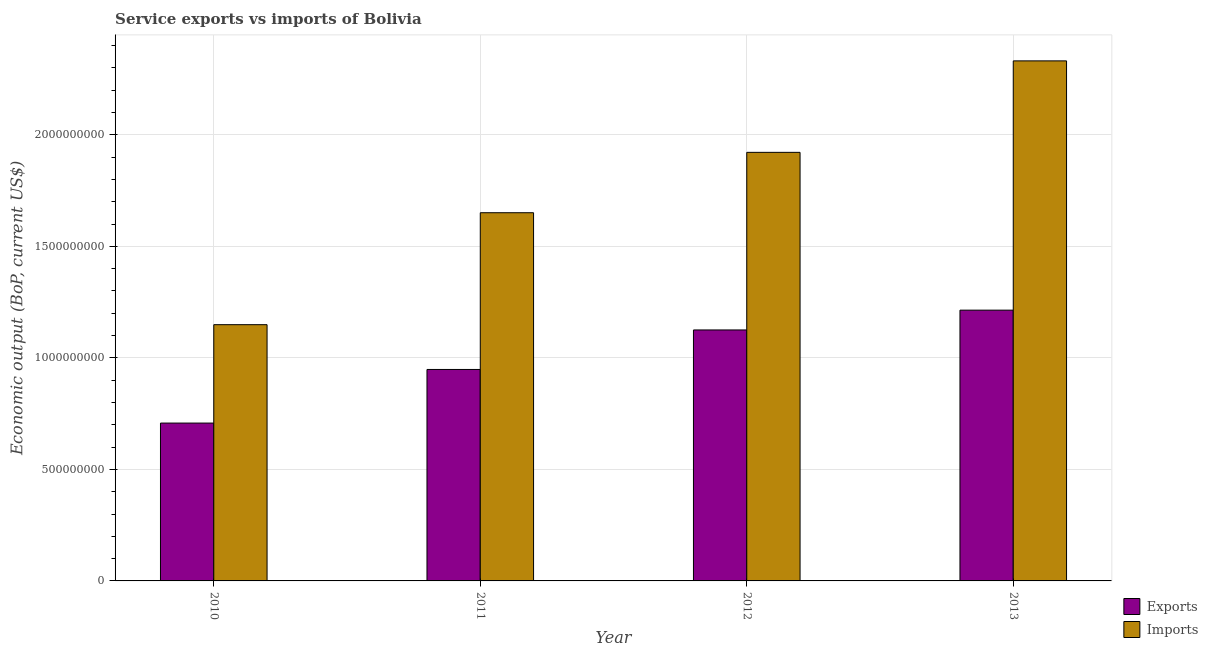How many groups of bars are there?
Ensure brevity in your answer.  4. Are the number of bars per tick equal to the number of legend labels?
Offer a very short reply. Yes. How many bars are there on the 4th tick from the left?
Your answer should be very brief. 2. How many bars are there on the 3rd tick from the right?
Offer a very short reply. 2. What is the label of the 1st group of bars from the left?
Your answer should be very brief. 2010. In how many cases, is the number of bars for a given year not equal to the number of legend labels?
Provide a short and direct response. 0. What is the amount of service imports in 2013?
Provide a succinct answer. 2.33e+09. Across all years, what is the maximum amount of service imports?
Keep it short and to the point. 2.33e+09. Across all years, what is the minimum amount of service imports?
Ensure brevity in your answer.  1.15e+09. In which year was the amount of service imports maximum?
Offer a terse response. 2013. In which year was the amount of service imports minimum?
Offer a very short reply. 2010. What is the total amount of service imports in the graph?
Make the answer very short. 7.05e+09. What is the difference between the amount of service exports in 2010 and that in 2011?
Provide a short and direct response. -2.40e+08. What is the difference between the amount of service exports in 2012 and the amount of service imports in 2010?
Your answer should be very brief. 4.17e+08. What is the average amount of service imports per year?
Your response must be concise. 1.76e+09. In the year 2013, what is the difference between the amount of service imports and amount of service exports?
Your answer should be compact. 0. In how many years, is the amount of service exports greater than 1000000000 US$?
Provide a short and direct response. 2. What is the ratio of the amount of service exports in 2010 to that in 2011?
Ensure brevity in your answer.  0.75. What is the difference between the highest and the second highest amount of service exports?
Give a very brief answer. 8.88e+07. What is the difference between the highest and the lowest amount of service imports?
Keep it short and to the point. 1.18e+09. Is the sum of the amount of service imports in 2010 and 2012 greater than the maximum amount of service exports across all years?
Provide a succinct answer. Yes. What does the 2nd bar from the left in 2013 represents?
Offer a terse response. Imports. What does the 2nd bar from the right in 2012 represents?
Offer a very short reply. Exports. How many bars are there?
Provide a succinct answer. 8. Are all the bars in the graph horizontal?
Your answer should be compact. No. Does the graph contain grids?
Your answer should be compact. Yes. What is the title of the graph?
Your answer should be very brief. Service exports vs imports of Bolivia. Does "Urban" appear as one of the legend labels in the graph?
Provide a short and direct response. No. What is the label or title of the X-axis?
Offer a terse response. Year. What is the label or title of the Y-axis?
Provide a short and direct response. Economic output (BoP, current US$). What is the Economic output (BoP, current US$) in Exports in 2010?
Your answer should be compact. 7.08e+08. What is the Economic output (BoP, current US$) in Imports in 2010?
Your response must be concise. 1.15e+09. What is the Economic output (BoP, current US$) of Exports in 2011?
Ensure brevity in your answer.  9.48e+08. What is the Economic output (BoP, current US$) in Imports in 2011?
Your answer should be very brief. 1.65e+09. What is the Economic output (BoP, current US$) of Exports in 2012?
Provide a succinct answer. 1.13e+09. What is the Economic output (BoP, current US$) of Imports in 2012?
Your response must be concise. 1.92e+09. What is the Economic output (BoP, current US$) in Exports in 2013?
Provide a succinct answer. 1.21e+09. What is the Economic output (BoP, current US$) in Imports in 2013?
Your response must be concise. 2.33e+09. Across all years, what is the maximum Economic output (BoP, current US$) in Exports?
Your answer should be compact. 1.21e+09. Across all years, what is the maximum Economic output (BoP, current US$) of Imports?
Your answer should be very brief. 2.33e+09. Across all years, what is the minimum Economic output (BoP, current US$) of Exports?
Make the answer very short. 7.08e+08. Across all years, what is the minimum Economic output (BoP, current US$) of Imports?
Your response must be concise. 1.15e+09. What is the total Economic output (BoP, current US$) of Exports in the graph?
Offer a very short reply. 3.99e+09. What is the total Economic output (BoP, current US$) in Imports in the graph?
Provide a short and direct response. 7.05e+09. What is the difference between the Economic output (BoP, current US$) of Exports in 2010 and that in 2011?
Provide a short and direct response. -2.40e+08. What is the difference between the Economic output (BoP, current US$) of Imports in 2010 and that in 2011?
Provide a short and direct response. -5.02e+08. What is the difference between the Economic output (BoP, current US$) of Exports in 2010 and that in 2012?
Provide a short and direct response. -4.17e+08. What is the difference between the Economic output (BoP, current US$) of Imports in 2010 and that in 2012?
Your answer should be very brief. -7.73e+08. What is the difference between the Economic output (BoP, current US$) in Exports in 2010 and that in 2013?
Provide a short and direct response. -5.06e+08. What is the difference between the Economic output (BoP, current US$) of Imports in 2010 and that in 2013?
Your response must be concise. -1.18e+09. What is the difference between the Economic output (BoP, current US$) of Exports in 2011 and that in 2012?
Provide a short and direct response. -1.77e+08. What is the difference between the Economic output (BoP, current US$) of Imports in 2011 and that in 2012?
Offer a terse response. -2.71e+08. What is the difference between the Economic output (BoP, current US$) in Exports in 2011 and that in 2013?
Your answer should be compact. -2.66e+08. What is the difference between the Economic output (BoP, current US$) in Imports in 2011 and that in 2013?
Your response must be concise. -6.81e+08. What is the difference between the Economic output (BoP, current US$) of Exports in 2012 and that in 2013?
Offer a terse response. -8.88e+07. What is the difference between the Economic output (BoP, current US$) of Imports in 2012 and that in 2013?
Keep it short and to the point. -4.10e+08. What is the difference between the Economic output (BoP, current US$) of Exports in 2010 and the Economic output (BoP, current US$) of Imports in 2011?
Your answer should be compact. -9.43e+08. What is the difference between the Economic output (BoP, current US$) of Exports in 2010 and the Economic output (BoP, current US$) of Imports in 2012?
Offer a very short reply. -1.21e+09. What is the difference between the Economic output (BoP, current US$) in Exports in 2010 and the Economic output (BoP, current US$) in Imports in 2013?
Your answer should be very brief. -1.62e+09. What is the difference between the Economic output (BoP, current US$) of Exports in 2011 and the Economic output (BoP, current US$) of Imports in 2012?
Give a very brief answer. -9.73e+08. What is the difference between the Economic output (BoP, current US$) of Exports in 2011 and the Economic output (BoP, current US$) of Imports in 2013?
Offer a very short reply. -1.38e+09. What is the difference between the Economic output (BoP, current US$) in Exports in 2012 and the Economic output (BoP, current US$) in Imports in 2013?
Your answer should be very brief. -1.21e+09. What is the average Economic output (BoP, current US$) of Exports per year?
Provide a succinct answer. 9.99e+08. What is the average Economic output (BoP, current US$) of Imports per year?
Provide a short and direct response. 1.76e+09. In the year 2010, what is the difference between the Economic output (BoP, current US$) of Exports and Economic output (BoP, current US$) of Imports?
Your answer should be compact. -4.41e+08. In the year 2011, what is the difference between the Economic output (BoP, current US$) of Exports and Economic output (BoP, current US$) of Imports?
Provide a succinct answer. -7.03e+08. In the year 2012, what is the difference between the Economic output (BoP, current US$) of Exports and Economic output (BoP, current US$) of Imports?
Your answer should be very brief. -7.96e+08. In the year 2013, what is the difference between the Economic output (BoP, current US$) in Exports and Economic output (BoP, current US$) in Imports?
Give a very brief answer. -1.12e+09. What is the ratio of the Economic output (BoP, current US$) of Exports in 2010 to that in 2011?
Give a very brief answer. 0.75. What is the ratio of the Economic output (BoP, current US$) of Imports in 2010 to that in 2011?
Ensure brevity in your answer.  0.7. What is the ratio of the Economic output (BoP, current US$) in Exports in 2010 to that in 2012?
Provide a succinct answer. 0.63. What is the ratio of the Economic output (BoP, current US$) of Imports in 2010 to that in 2012?
Offer a very short reply. 0.6. What is the ratio of the Economic output (BoP, current US$) in Exports in 2010 to that in 2013?
Ensure brevity in your answer.  0.58. What is the ratio of the Economic output (BoP, current US$) in Imports in 2010 to that in 2013?
Your answer should be very brief. 0.49. What is the ratio of the Economic output (BoP, current US$) in Exports in 2011 to that in 2012?
Offer a very short reply. 0.84. What is the ratio of the Economic output (BoP, current US$) of Imports in 2011 to that in 2012?
Your answer should be very brief. 0.86. What is the ratio of the Economic output (BoP, current US$) of Exports in 2011 to that in 2013?
Your response must be concise. 0.78. What is the ratio of the Economic output (BoP, current US$) in Imports in 2011 to that in 2013?
Your response must be concise. 0.71. What is the ratio of the Economic output (BoP, current US$) of Exports in 2012 to that in 2013?
Offer a very short reply. 0.93. What is the ratio of the Economic output (BoP, current US$) in Imports in 2012 to that in 2013?
Ensure brevity in your answer.  0.82. What is the difference between the highest and the second highest Economic output (BoP, current US$) of Exports?
Keep it short and to the point. 8.88e+07. What is the difference between the highest and the second highest Economic output (BoP, current US$) in Imports?
Keep it short and to the point. 4.10e+08. What is the difference between the highest and the lowest Economic output (BoP, current US$) of Exports?
Keep it short and to the point. 5.06e+08. What is the difference between the highest and the lowest Economic output (BoP, current US$) in Imports?
Provide a short and direct response. 1.18e+09. 